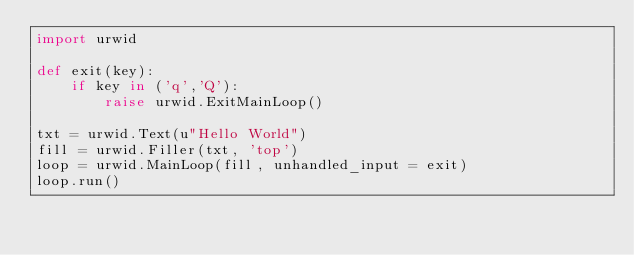Convert code to text. <code><loc_0><loc_0><loc_500><loc_500><_Python_>import urwid

def exit(key):
    if key in ('q','Q'):
        raise urwid.ExitMainLoop()

txt = urwid.Text(u"Hello World")
fill = urwid.Filler(txt, 'top')
loop = urwid.MainLoop(fill, unhandled_input = exit)
loop.run()

</code> 